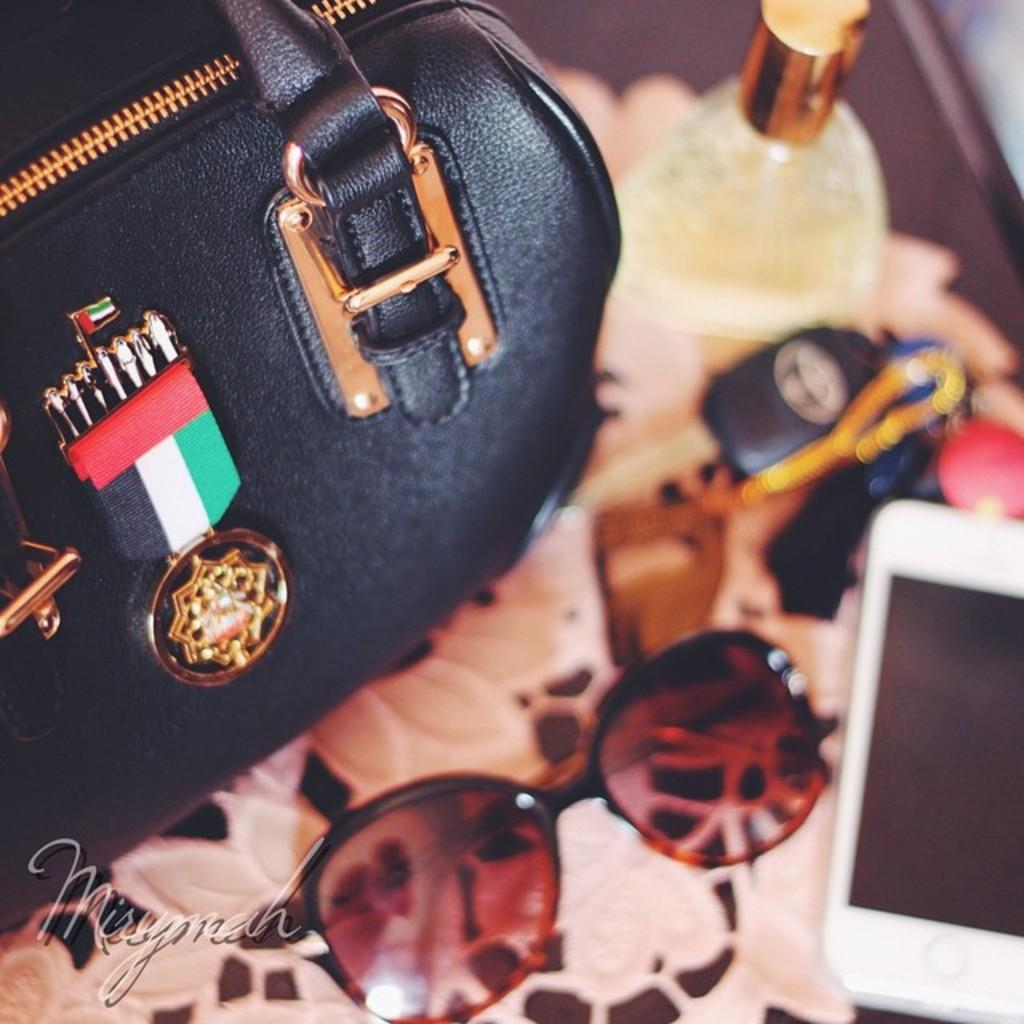What object is located on the left side of the image? There is a handbag on the left side of the image. What can be seen in the image besides the handbag? There is a flag and sunglasses visible in the image. What is the nature of the objects on the table in the image? The objects on the table in the image are not specified, but their presence is mentioned. What direction is the wind blowing in the image? There is no indication of wind or its direction in the image. What color is the sky in the image? The color of the sky is not mentioned in the image. 